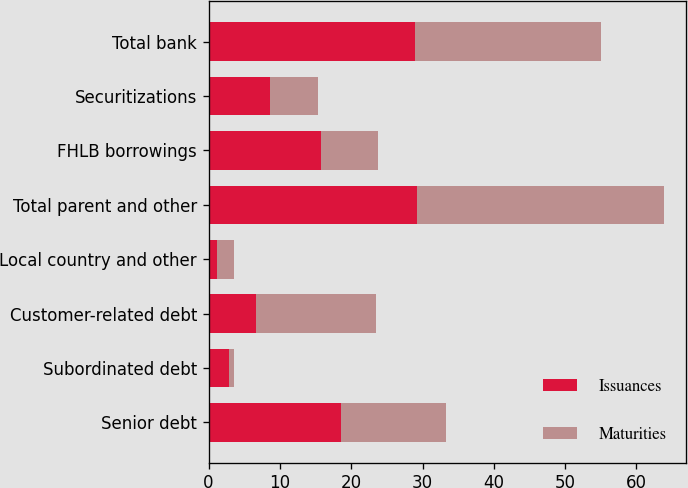Convert chart. <chart><loc_0><loc_0><loc_500><loc_500><stacked_bar_chart><ecel><fcel>Senior debt<fcel>Subordinated debt<fcel>Customer-related debt<fcel>Local country and other<fcel>Total parent and other<fcel>FHLB borrowings<fcel>Securitizations<fcel>Total bank<nl><fcel>Issuances<fcel>18.5<fcel>2.9<fcel>6.6<fcel>1.2<fcel>29.2<fcel>15.8<fcel>8.6<fcel>28.9<nl><fcel>Maturities<fcel>14.8<fcel>0.6<fcel>16.9<fcel>2.3<fcel>34.6<fcel>7.9<fcel>6.8<fcel>26.1<nl></chart> 